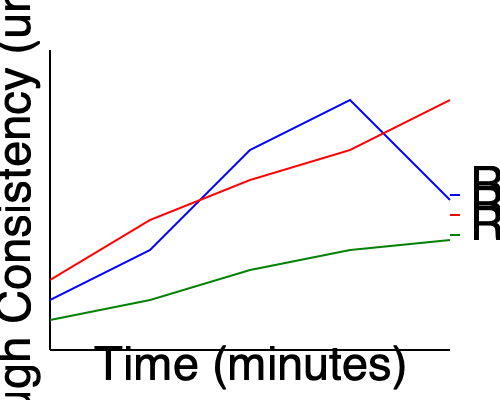Based on the graph showing dough consistency over time for three different recipes, which recipe would you recommend to a bakery owner looking to achieve the most stable dough consistency throughout the mixing process? To determine which recipe provides the most stable dough consistency, we need to analyze the graph for each recipe:

1. Recipe A (blue line):
   - Starts at a high consistency
   - Decreases sharply in the first half
   - Increases slightly towards the end
   - Shows significant variation over time

2. Recipe B (red line):
   - Starts at a medium-high consistency
   - Decreases steadily throughout the process
   - Ends at the lowest consistency
   - Shows consistent decline but not stability

3. Recipe C (green line):
   - Starts at the highest consistency
   - Decreases slightly in the beginning
   - Levels off and remains relatively constant for the latter half
   - Shows the least variation over time

Comparing the three recipes, Recipe C demonstrates the most stable dough consistency throughout the mixing process. It has the least dramatic changes and maintains a relatively constant consistency after an initial slight decrease.

For a bakery owner seeking stable dough consistency, Recipe C would be the best recommendation. Stable dough consistency is crucial for maintaining product quality and ensuring efficient production processes in an automated bakery setting.
Answer: Recipe C 